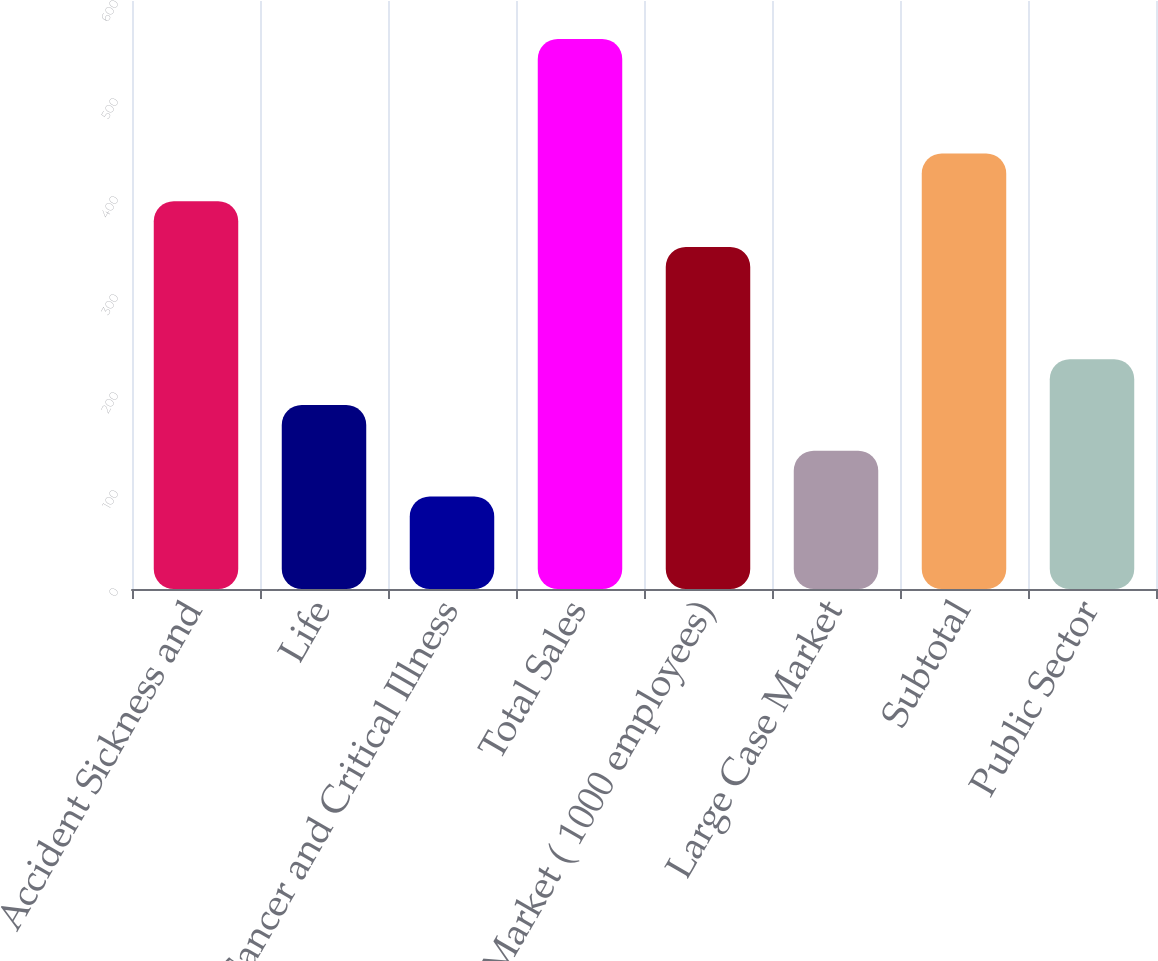Convert chart. <chart><loc_0><loc_0><loc_500><loc_500><bar_chart><fcel>Accident Sickness and<fcel>Life<fcel>Cancer and Critical Illness<fcel>Total Sales<fcel>Core Market ( 1000 employees)<fcel>Large Case Market<fcel>Subtotal<fcel>Public Sector<nl><fcel>395.69<fcel>187.78<fcel>94.4<fcel>561.3<fcel>349<fcel>141.09<fcel>444.5<fcel>234.47<nl></chart> 